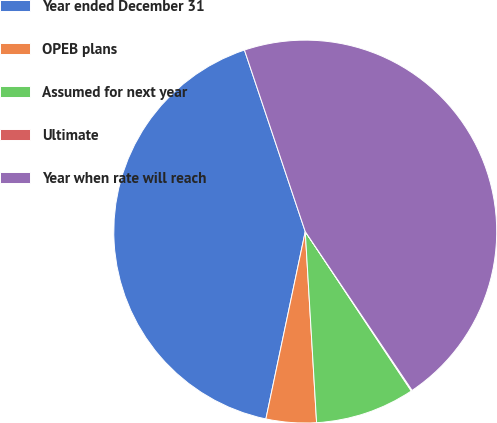Convert chart to OTSL. <chart><loc_0><loc_0><loc_500><loc_500><pie_chart><fcel>Year ended December 31<fcel>OPEB plans<fcel>Assumed for next year<fcel>Ultimate<fcel>Year when rate will reach<nl><fcel>41.56%<fcel>4.24%<fcel>8.4%<fcel>0.08%<fcel>45.72%<nl></chart> 